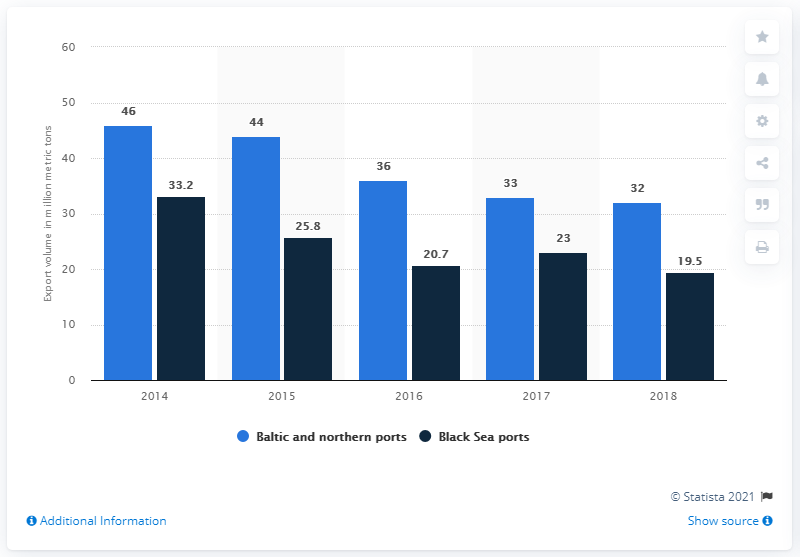Highlight a few significant elements in this photo. In 2018, the Baltic and northern ports accounted for approximately 32 metric tons of fuel oil exports. According to statistics from 2018, approximately 19.5% of the total export volume in Black Sea ports was recorded. The sum of ports in 2017 is 56. 